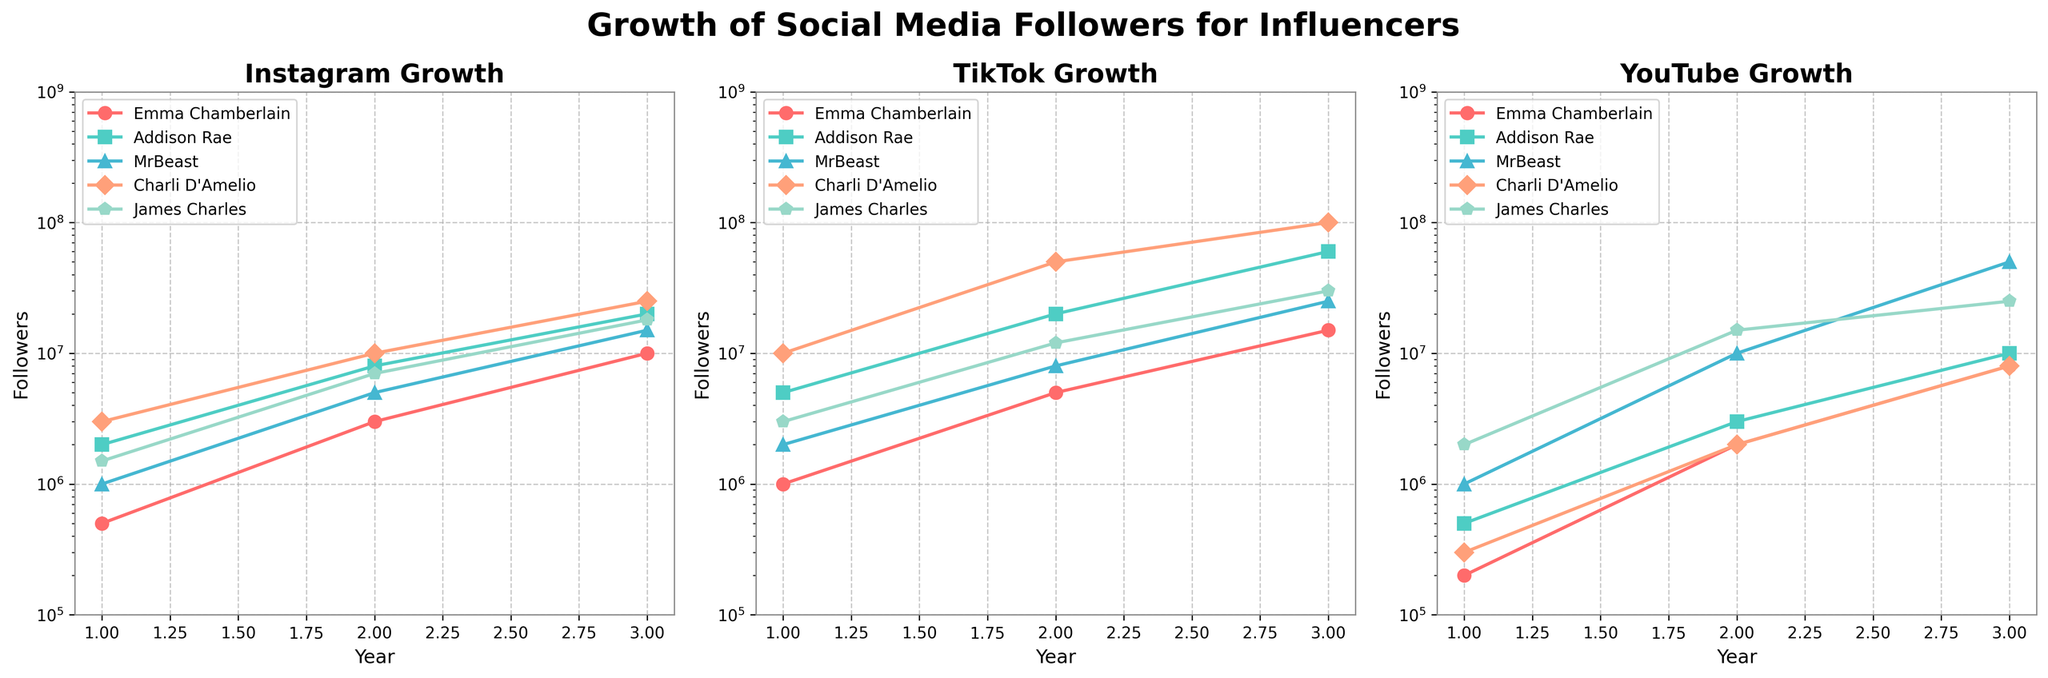What is the growth trend of Emma Chamberlain on YouTube compared to Instagram over the 3 years? Emma Chamberlain's YouTube followers started at 200,000 in the first year and grew to 800,000 in the third year, while her Instagram followers started at 500,000 and grew to 10,000,000. This indicates her growth on Instagram is significantly higher.
Answer: Emma Chamberlain's Instagram growth is significantly higher Which influencer had the largest follower growth on TikTok in the second year? In the second year on TikTok, Charli D'Amelio had the most followers, growing from 10,000,000 in the first year to 50,000,000 followers in the second year. This shows the largest growth.
Answer: Charli D'Amelio How does James Charles' follower count on Instagram in the third year compare to his YouTube followers? In the third year, James Charles had 18,000,000 followers on Instagram compared to 25,000,000 followers on YouTube. Thus, his followers are higher on YouTube by 7,000,000.
Answer: James Charles has 7,000,000 more followers on YouTube than Instagram What is the average number of Instagram followers for the influencers in the second year? The data shows the following followers in the second year on Instagram: 3,000,000 (Emma Chamberlain), 8,000,000 (Addison Rae), 5,000,000 (MrBeast), 10,000,000 (Charli D'Amelio), 7,000,000 (James Charles). Summing these up (3,000,000 + 8,000,000 + 5,000,000 + 10,000,000 + 7,000,000) equals 33,000,000, and the average is 33,000,000 / 5 = 6,600,000.
Answer: 6,600,000 Which influencer has a steeper growth curve on TikTok relative to Instagram? By examining the followers' growth visually, Charli D'Amelio shows a steeper curve on TikTok, growing from 10,000,000 to 100,000,000 over 3 years compared to her Instagram followers' growth from 3,000,000 to 25,000,000.
Answer: Charli D'Amelio Which platform shows a more dramatic increase in followers for MrBeast between years 2 and 3? On TikTok, MrBeast's followers increased from 8,000,000 to 25,000,000 between years 2 and 3, compared with an increase from 10,000,000 to 50,000,000 on YouTube. His growth on YouTube is more dramatic.
Answer: YouTube Who had the smallest growth on any platform from year 1 to year 3? On YouTube, Emma Chamberlain had the smallest growth, going from 200,000 followers in year 1 to 8,000,000 in year 3. This shows relatively smaller growth compared to other influencers.
Answer: Emma Chamberlain on YouTube 